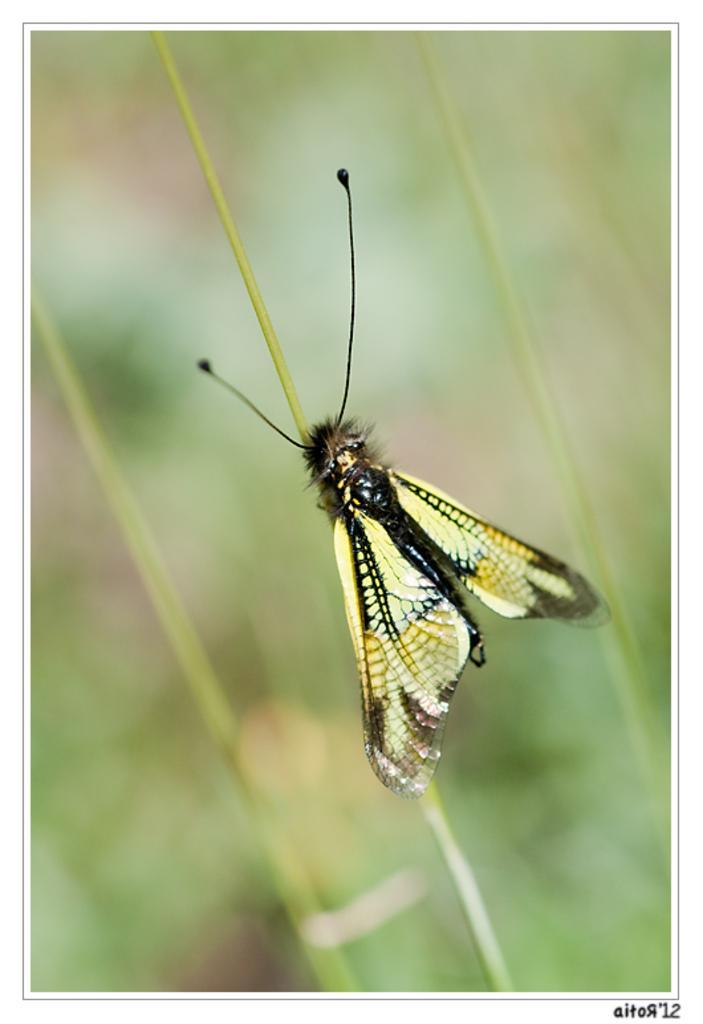Can you describe this image briefly? In the image there is a butterfly laying on a grass and the background of the butterfly is blue. 